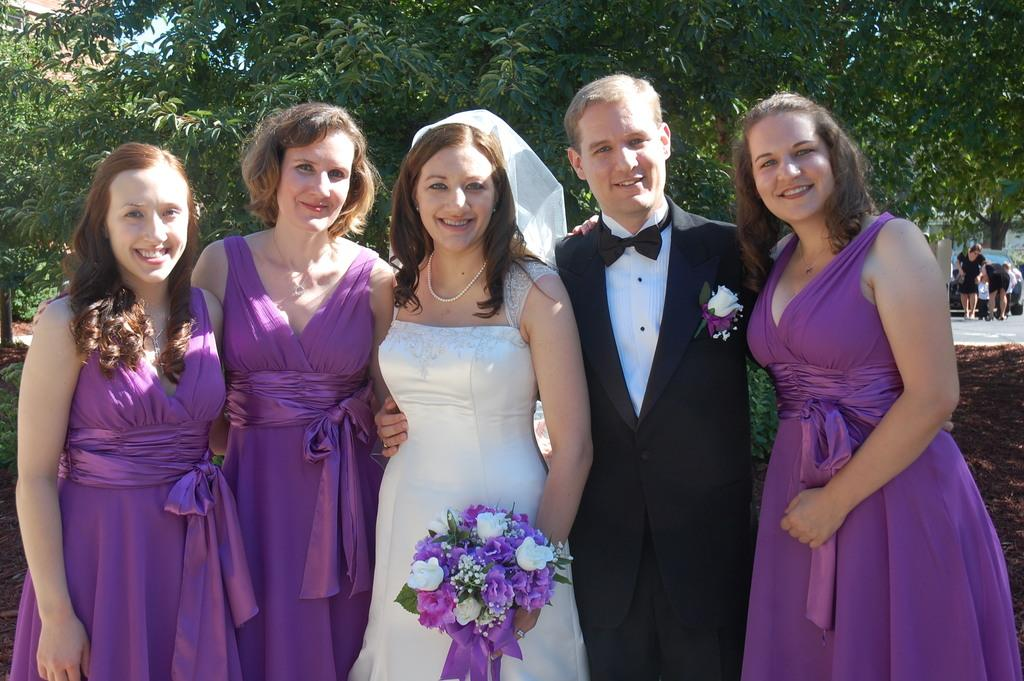What are the people in the center of the image doing? The people in the center of the image are standing. What is the lady in the center holding? The lady in the center is holding a bouquet. What can be seen in the background of the image? There are trees and people visible in the background of the image. What type of gate is visible in the image? There is no gate present in the image. What loss is being offered by the people in the image? There is no mention of a loss or an offer in the image. 